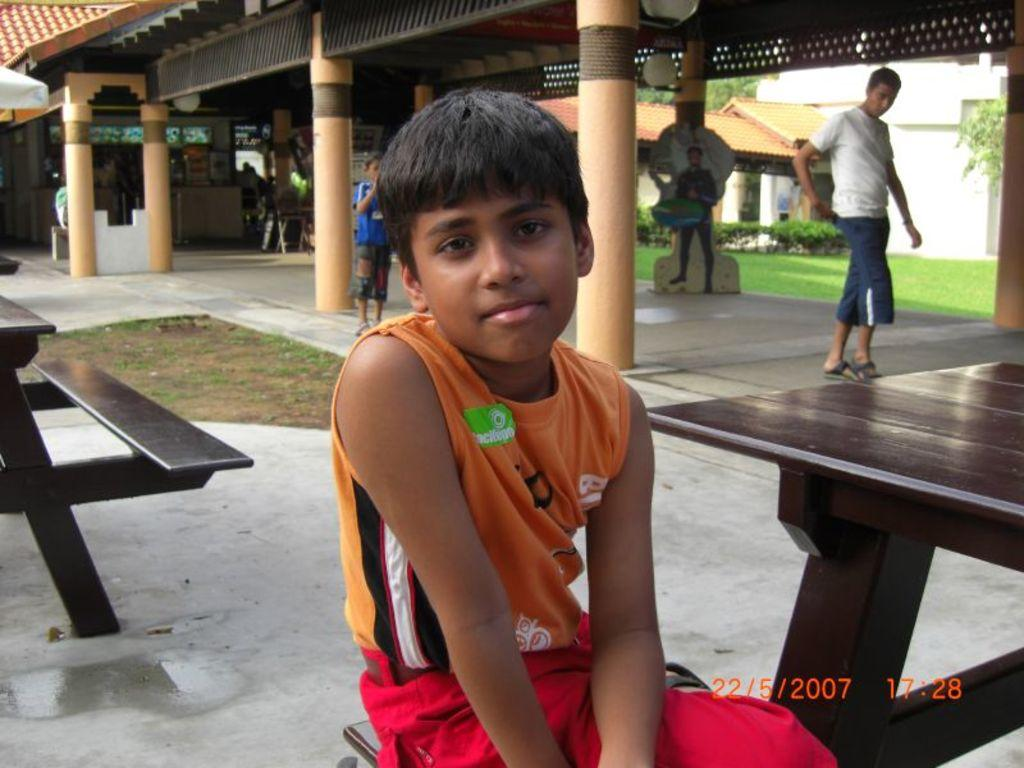What is the boy doing in the image? The boy is seated on a bench in the image. What is the man doing in the image? The man is walking in the image. What type of structure can be seen in the image? There is a house in the image. What type of vegetation is present in the image? There is a tree in the image. What type of current is flowing through the tree in the image? There is no indication of any current, electrical or otherwise, in the image. What act is the tree performing in the image? The tree is not performing any act; it is a stationary object in the image. 